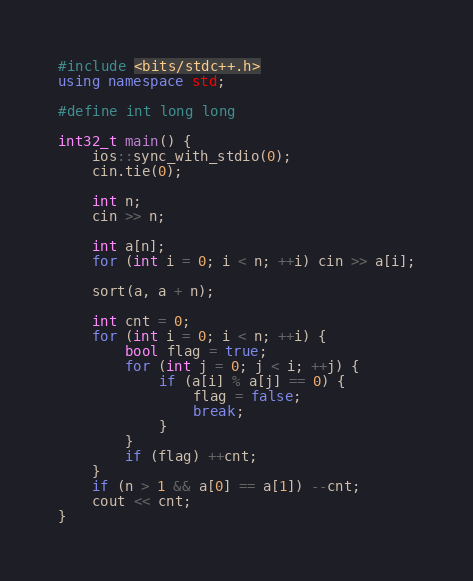Convert code to text. <code><loc_0><loc_0><loc_500><loc_500><_C++_>#include <bits/stdc++.h>
using namespace std;

#define int long long

int32_t main() {
	ios::sync_with_stdio(0);
	cin.tie(0);

	int n;
	cin >> n;

	int a[n];
	for (int i = 0; i < n; ++i) cin >> a[i];

	sort(a, a + n);

	int cnt = 0;
	for (int i = 0; i < n; ++i) {
		bool flag = true;
		for (int j = 0; j < i; ++j) {
			if (a[i] % a[j] == 0) {
				flag = false;
				break;
			}
		}
		if (flag) ++cnt;
	}
	if (n > 1 && a[0] == a[1]) --cnt;
	cout << cnt;
}
</code> 